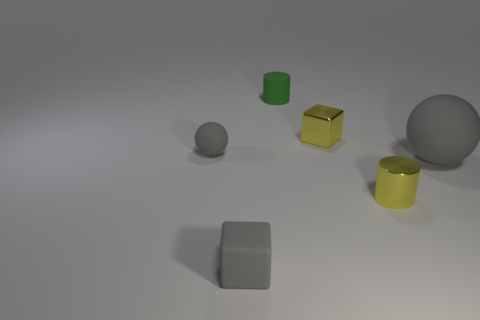What number of tiny things have the same color as the tiny shiny cylinder?
Offer a very short reply. 1. There is a tiny shiny cylinder; is its color the same as the rubber ball that is right of the green cylinder?
Ensure brevity in your answer.  No. There is a small green matte cylinder; how many small matte blocks are behind it?
Your answer should be very brief. 0. Are there fewer gray matte things behind the green cylinder than big blue rubber spheres?
Ensure brevity in your answer.  No. The shiny block has what color?
Provide a succinct answer. Yellow. There is a cube that is on the left side of the matte cylinder; is its color the same as the large rubber thing?
Provide a succinct answer. Yes. There is another thing that is the same shape as the large gray object; what color is it?
Keep it short and to the point. Gray. What number of big things are cylinders or purple rubber balls?
Your answer should be very brief. 0. How big is the sphere that is right of the small green object?
Your answer should be compact. Large. Are there any objects of the same color as the tiny shiny cylinder?
Provide a succinct answer. Yes. 